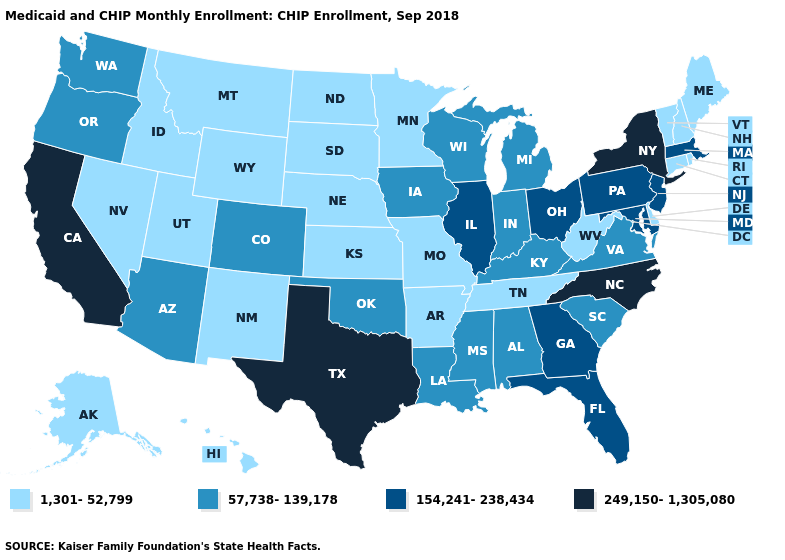Does the first symbol in the legend represent the smallest category?
Give a very brief answer. Yes. What is the value of Idaho?
Quick response, please. 1,301-52,799. Does Louisiana have the lowest value in the USA?
Keep it brief. No. Does Massachusetts have the same value as Georgia?
Quick response, please. Yes. What is the value of New Jersey?
Answer briefly. 154,241-238,434. What is the value of Connecticut?
Give a very brief answer. 1,301-52,799. Name the states that have a value in the range 249,150-1,305,080?
Answer briefly. California, New York, North Carolina, Texas. Does South Carolina have the same value as Tennessee?
Quick response, please. No. What is the value of Hawaii?
Give a very brief answer. 1,301-52,799. Name the states that have a value in the range 154,241-238,434?
Short answer required. Florida, Georgia, Illinois, Maryland, Massachusetts, New Jersey, Ohio, Pennsylvania. What is the value of Delaware?
Be succinct. 1,301-52,799. Does Mississippi have the lowest value in the USA?
Be succinct. No. What is the value of Alaska?
Short answer required. 1,301-52,799. Among the states that border Ohio , does Indiana have the lowest value?
Short answer required. No. 